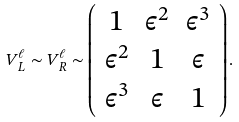<formula> <loc_0><loc_0><loc_500><loc_500>V _ { L } ^ { \ell } \sim V _ { R } ^ { \ell } \sim \left ( \begin{array} { c c c } 1 & \epsilon ^ { 2 } & \epsilon ^ { 3 } \\ \epsilon ^ { 2 } & 1 & \epsilon \\ \epsilon ^ { 3 } & \epsilon & 1 \end{array} \right ) .</formula> 